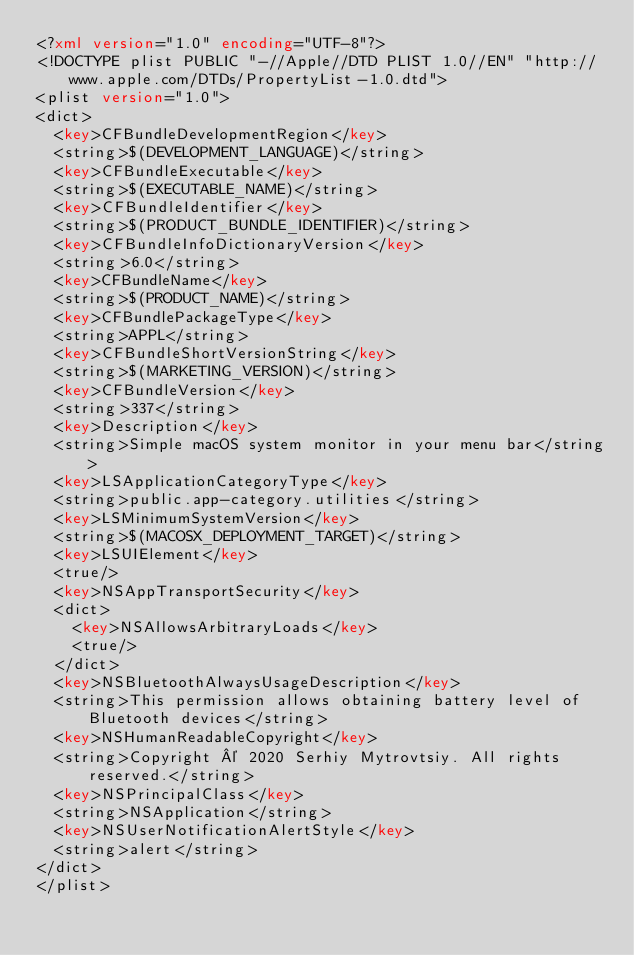<code> <loc_0><loc_0><loc_500><loc_500><_XML_><?xml version="1.0" encoding="UTF-8"?>
<!DOCTYPE plist PUBLIC "-//Apple//DTD PLIST 1.0//EN" "http://www.apple.com/DTDs/PropertyList-1.0.dtd">
<plist version="1.0">
<dict>
	<key>CFBundleDevelopmentRegion</key>
	<string>$(DEVELOPMENT_LANGUAGE)</string>
	<key>CFBundleExecutable</key>
	<string>$(EXECUTABLE_NAME)</string>
	<key>CFBundleIdentifier</key>
	<string>$(PRODUCT_BUNDLE_IDENTIFIER)</string>
	<key>CFBundleInfoDictionaryVersion</key>
	<string>6.0</string>
	<key>CFBundleName</key>
	<string>$(PRODUCT_NAME)</string>
	<key>CFBundlePackageType</key>
	<string>APPL</string>
	<key>CFBundleShortVersionString</key>
	<string>$(MARKETING_VERSION)</string>
	<key>CFBundleVersion</key>
	<string>337</string>
	<key>Description</key>
	<string>Simple macOS system monitor in your menu bar</string>
	<key>LSApplicationCategoryType</key>
	<string>public.app-category.utilities</string>
	<key>LSMinimumSystemVersion</key>
	<string>$(MACOSX_DEPLOYMENT_TARGET)</string>
	<key>LSUIElement</key>
	<true/>
	<key>NSAppTransportSecurity</key>
	<dict>
		<key>NSAllowsArbitraryLoads</key>
		<true/>
	</dict>
	<key>NSBluetoothAlwaysUsageDescription</key>
	<string>This permission allows obtaining battery level of Bluetooth devices</string>
	<key>NSHumanReadableCopyright</key>
	<string>Copyright © 2020 Serhiy Mytrovtsiy. All rights reserved.</string>
	<key>NSPrincipalClass</key>
	<string>NSApplication</string>
	<key>NSUserNotificationAlertStyle</key>
	<string>alert</string>
</dict>
</plist>
</code> 